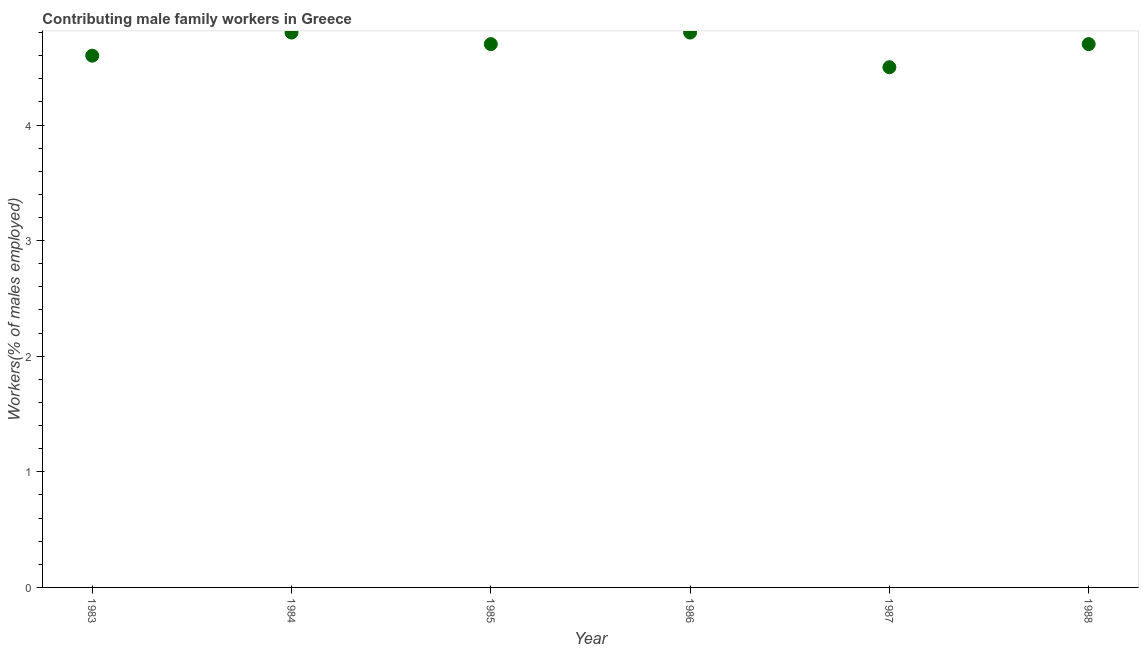What is the contributing male family workers in 1985?
Your answer should be compact. 4.7. Across all years, what is the maximum contributing male family workers?
Provide a short and direct response. 4.8. What is the sum of the contributing male family workers?
Your response must be concise. 28.1. What is the difference between the contributing male family workers in 1985 and 1987?
Make the answer very short. 0.2. What is the average contributing male family workers per year?
Your response must be concise. 4.68. What is the median contributing male family workers?
Provide a short and direct response. 4.7. In how many years, is the contributing male family workers greater than 1 %?
Keep it short and to the point. 6. Do a majority of the years between 1986 and 1984 (inclusive) have contributing male family workers greater than 2.2 %?
Make the answer very short. No. What is the ratio of the contributing male family workers in 1983 to that in 1986?
Your response must be concise. 0.96. What is the difference between the highest and the lowest contributing male family workers?
Ensure brevity in your answer.  0.3. How many dotlines are there?
Provide a succinct answer. 1. Are the values on the major ticks of Y-axis written in scientific E-notation?
Your answer should be very brief. No. Does the graph contain any zero values?
Offer a terse response. No. Does the graph contain grids?
Offer a very short reply. No. What is the title of the graph?
Offer a very short reply. Contributing male family workers in Greece. What is the label or title of the X-axis?
Make the answer very short. Year. What is the label or title of the Y-axis?
Keep it short and to the point. Workers(% of males employed). What is the Workers(% of males employed) in 1983?
Make the answer very short. 4.6. What is the Workers(% of males employed) in 1984?
Provide a succinct answer. 4.8. What is the Workers(% of males employed) in 1985?
Offer a very short reply. 4.7. What is the Workers(% of males employed) in 1986?
Your answer should be very brief. 4.8. What is the Workers(% of males employed) in 1987?
Make the answer very short. 4.5. What is the Workers(% of males employed) in 1988?
Provide a succinct answer. 4.7. What is the difference between the Workers(% of males employed) in 1983 and 1986?
Your answer should be very brief. -0.2. What is the difference between the Workers(% of males employed) in 1984 and 1985?
Ensure brevity in your answer.  0.1. What is the difference between the Workers(% of males employed) in 1984 and 1987?
Your answer should be compact. 0.3. What is the difference between the Workers(% of males employed) in 1984 and 1988?
Offer a terse response. 0.1. What is the difference between the Workers(% of males employed) in 1985 and 1986?
Ensure brevity in your answer.  -0.1. What is the difference between the Workers(% of males employed) in 1986 and 1988?
Give a very brief answer. 0.1. What is the ratio of the Workers(% of males employed) in 1983 to that in 1984?
Ensure brevity in your answer.  0.96. What is the ratio of the Workers(% of males employed) in 1983 to that in 1985?
Keep it short and to the point. 0.98. What is the ratio of the Workers(% of males employed) in 1983 to that in 1986?
Your response must be concise. 0.96. What is the ratio of the Workers(% of males employed) in 1983 to that in 1987?
Keep it short and to the point. 1.02. What is the ratio of the Workers(% of males employed) in 1984 to that in 1985?
Make the answer very short. 1.02. What is the ratio of the Workers(% of males employed) in 1984 to that in 1986?
Your answer should be very brief. 1. What is the ratio of the Workers(% of males employed) in 1984 to that in 1987?
Your answer should be compact. 1.07. What is the ratio of the Workers(% of males employed) in 1985 to that in 1987?
Your answer should be very brief. 1.04. What is the ratio of the Workers(% of males employed) in 1986 to that in 1987?
Provide a succinct answer. 1.07. What is the ratio of the Workers(% of males employed) in 1987 to that in 1988?
Offer a very short reply. 0.96. 